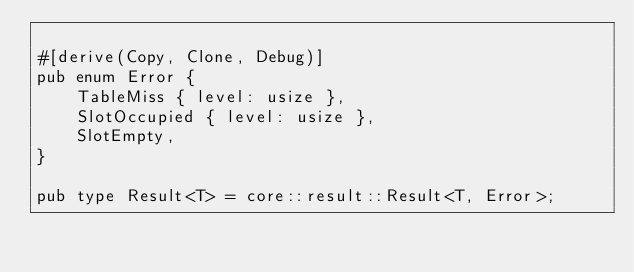Convert code to text. <code><loc_0><loc_0><loc_500><loc_500><_Rust_>
#[derive(Copy, Clone, Debug)]
pub enum Error {
    TableMiss { level: usize },
    SlotOccupied { level: usize },
    SlotEmpty,
}

pub type Result<T> = core::result::Result<T, Error>;</code> 